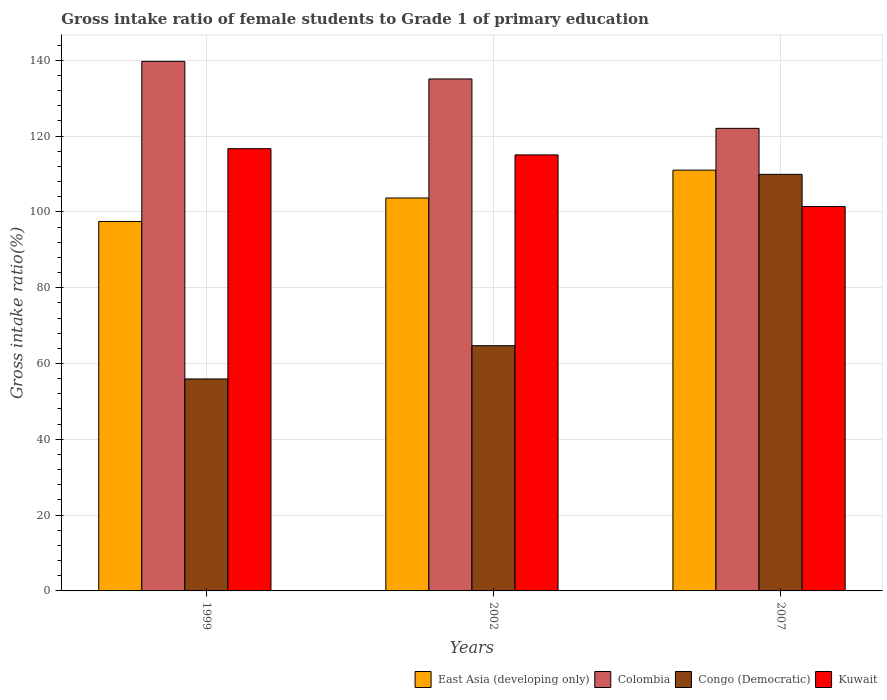How many different coloured bars are there?
Your answer should be compact. 4. Are the number of bars per tick equal to the number of legend labels?
Your answer should be very brief. Yes. Are the number of bars on each tick of the X-axis equal?
Provide a succinct answer. Yes. How many bars are there on the 2nd tick from the left?
Your response must be concise. 4. What is the gross intake ratio in Colombia in 2002?
Offer a terse response. 135.07. Across all years, what is the maximum gross intake ratio in East Asia (developing only)?
Ensure brevity in your answer.  111.01. Across all years, what is the minimum gross intake ratio in East Asia (developing only)?
Your response must be concise. 97.48. What is the total gross intake ratio in Kuwait in the graph?
Keep it short and to the point. 333.11. What is the difference between the gross intake ratio in Colombia in 1999 and that in 2002?
Provide a succinct answer. 4.64. What is the difference between the gross intake ratio in Kuwait in 2007 and the gross intake ratio in Colombia in 2002?
Your answer should be compact. -33.66. What is the average gross intake ratio in Colombia per year?
Your answer should be compact. 132.27. In the year 2002, what is the difference between the gross intake ratio in East Asia (developing only) and gross intake ratio in Colombia?
Offer a terse response. -31.41. What is the ratio of the gross intake ratio in Kuwait in 2002 to that in 2007?
Offer a terse response. 1.13. Is the gross intake ratio in Kuwait in 1999 less than that in 2007?
Offer a terse response. No. What is the difference between the highest and the second highest gross intake ratio in Congo (Democratic)?
Give a very brief answer. 45.2. What is the difference between the highest and the lowest gross intake ratio in Colombia?
Ensure brevity in your answer.  17.68. In how many years, is the gross intake ratio in Congo (Democratic) greater than the average gross intake ratio in Congo (Democratic) taken over all years?
Ensure brevity in your answer.  1. What does the 4th bar from the right in 1999 represents?
Give a very brief answer. East Asia (developing only). Is it the case that in every year, the sum of the gross intake ratio in Congo (Democratic) and gross intake ratio in East Asia (developing only) is greater than the gross intake ratio in Kuwait?
Provide a short and direct response. Yes. How many years are there in the graph?
Provide a succinct answer. 3. Are the values on the major ticks of Y-axis written in scientific E-notation?
Your response must be concise. No. Does the graph contain grids?
Keep it short and to the point. Yes. Where does the legend appear in the graph?
Your response must be concise. Bottom right. How are the legend labels stacked?
Your answer should be compact. Horizontal. What is the title of the graph?
Your answer should be compact. Gross intake ratio of female students to Grade 1 of primary education. Does "Philippines" appear as one of the legend labels in the graph?
Offer a very short reply. No. What is the label or title of the Y-axis?
Your response must be concise. Gross intake ratio(%). What is the Gross intake ratio(%) of East Asia (developing only) in 1999?
Your answer should be compact. 97.48. What is the Gross intake ratio(%) of Colombia in 1999?
Provide a short and direct response. 139.71. What is the Gross intake ratio(%) of Congo (Democratic) in 1999?
Your response must be concise. 55.92. What is the Gross intake ratio(%) of Kuwait in 1999?
Your answer should be compact. 116.68. What is the Gross intake ratio(%) in East Asia (developing only) in 2002?
Offer a terse response. 103.66. What is the Gross intake ratio(%) in Colombia in 2002?
Your answer should be compact. 135.07. What is the Gross intake ratio(%) of Congo (Democratic) in 2002?
Offer a very short reply. 64.7. What is the Gross intake ratio(%) of Kuwait in 2002?
Give a very brief answer. 115.03. What is the Gross intake ratio(%) in East Asia (developing only) in 2007?
Provide a succinct answer. 111.01. What is the Gross intake ratio(%) in Colombia in 2007?
Your response must be concise. 122.04. What is the Gross intake ratio(%) of Congo (Democratic) in 2007?
Provide a short and direct response. 109.9. What is the Gross intake ratio(%) of Kuwait in 2007?
Offer a very short reply. 101.4. Across all years, what is the maximum Gross intake ratio(%) of East Asia (developing only)?
Your answer should be compact. 111.01. Across all years, what is the maximum Gross intake ratio(%) in Colombia?
Offer a very short reply. 139.71. Across all years, what is the maximum Gross intake ratio(%) of Congo (Democratic)?
Offer a terse response. 109.9. Across all years, what is the maximum Gross intake ratio(%) in Kuwait?
Make the answer very short. 116.68. Across all years, what is the minimum Gross intake ratio(%) of East Asia (developing only)?
Your response must be concise. 97.48. Across all years, what is the minimum Gross intake ratio(%) of Colombia?
Provide a succinct answer. 122.04. Across all years, what is the minimum Gross intake ratio(%) in Congo (Democratic)?
Your answer should be compact. 55.92. Across all years, what is the minimum Gross intake ratio(%) of Kuwait?
Provide a short and direct response. 101.4. What is the total Gross intake ratio(%) of East Asia (developing only) in the graph?
Ensure brevity in your answer.  312.15. What is the total Gross intake ratio(%) in Colombia in the graph?
Provide a short and direct response. 396.82. What is the total Gross intake ratio(%) of Congo (Democratic) in the graph?
Your response must be concise. 230.52. What is the total Gross intake ratio(%) in Kuwait in the graph?
Your answer should be very brief. 333.11. What is the difference between the Gross intake ratio(%) in East Asia (developing only) in 1999 and that in 2002?
Make the answer very short. -6.19. What is the difference between the Gross intake ratio(%) of Colombia in 1999 and that in 2002?
Provide a short and direct response. 4.64. What is the difference between the Gross intake ratio(%) in Congo (Democratic) in 1999 and that in 2002?
Keep it short and to the point. -8.78. What is the difference between the Gross intake ratio(%) of Kuwait in 1999 and that in 2002?
Offer a terse response. 1.65. What is the difference between the Gross intake ratio(%) of East Asia (developing only) in 1999 and that in 2007?
Give a very brief answer. -13.53. What is the difference between the Gross intake ratio(%) of Colombia in 1999 and that in 2007?
Offer a terse response. 17.68. What is the difference between the Gross intake ratio(%) in Congo (Democratic) in 1999 and that in 2007?
Provide a short and direct response. -53.97. What is the difference between the Gross intake ratio(%) of Kuwait in 1999 and that in 2007?
Give a very brief answer. 15.27. What is the difference between the Gross intake ratio(%) of East Asia (developing only) in 2002 and that in 2007?
Make the answer very short. -7.35. What is the difference between the Gross intake ratio(%) in Colombia in 2002 and that in 2007?
Your answer should be very brief. 13.03. What is the difference between the Gross intake ratio(%) in Congo (Democratic) in 2002 and that in 2007?
Provide a short and direct response. -45.2. What is the difference between the Gross intake ratio(%) in Kuwait in 2002 and that in 2007?
Your answer should be very brief. 13.63. What is the difference between the Gross intake ratio(%) in East Asia (developing only) in 1999 and the Gross intake ratio(%) in Colombia in 2002?
Ensure brevity in your answer.  -37.59. What is the difference between the Gross intake ratio(%) of East Asia (developing only) in 1999 and the Gross intake ratio(%) of Congo (Democratic) in 2002?
Your response must be concise. 32.77. What is the difference between the Gross intake ratio(%) of East Asia (developing only) in 1999 and the Gross intake ratio(%) of Kuwait in 2002?
Offer a terse response. -17.56. What is the difference between the Gross intake ratio(%) of Colombia in 1999 and the Gross intake ratio(%) of Congo (Democratic) in 2002?
Provide a short and direct response. 75.01. What is the difference between the Gross intake ratio(%) in Colombia in 1999 and the Gross intake ratio(%) in Kuwait in 2002?
Give a very brief answer. 24.68. What is the difference between the Gross intake ratio(%) in Congo (Democratic) in 1999 and the Gross intake ratio(%) in Kuwait in 2002?
Offer a very short reply. -59.11. What is the difference between the Gross intake ratio(%) of East Asia (developing only) in 1999 and the Gross intake ratio(%) of Colombia in 2007?
Offer a very short reply. -24.56. What is the difference between the Gross intake ratio(%) of East Asia (developing only) in 1999 and the Gross intake ratio(%) of Congo (Democratic) in 2007?
Your response must be concise. -12.42. What is the difference between the Gross intake ratio(%) of East Asia (developing only) in 1999 and the Gross intake ratio(%) of Kuwait in 2007?
Give a very brief answer. -3.93. What is the difference between the Gross intake ratio(%) in Colombia in 1999 and the Gross intake ratio(%) in Congo (Democratic) in 2007?
Offer a very short reply. 29.82. What is the difference between the Gross intake ratio(%) in Colombia in 1999 and the Gross intake ratio(%) in Kuwait in 2007?
Make the answer very short. 38.31. What is the difference between the Gross intake ratio(%) of Congo (Democratic) in 1999 and the Gross intake ratio(%) of Kuwait in 2007?
Give a very brief answer. -45.48. What is the difference between the Gross intake ratio(%) of East Asia (developing only) in 2002 and the Gross intake ratio(%) of Colombia in 2007?
Provide a short and direct response. -18.37. What is the difference between the Gross intake ratio(%) of East Asia (developing only) in 2002 and the Gross intake ratio(%) of Congo (Democratic) in 2007?
Ensure brevity in your answer.  -6.23. What is the difference between the Gross intake ratio(%) in East Asia (developing only) in 2002 and the Gross intake ratio(%) in Kuwait in 2007?
Keep it short and to the point. 2.26. What is the difference between the Gross intake ratio(%) in Colombia in 2002 and the Gross intake ratio(%) in Congo (Democratic) in 2007?
Provide a succinct answer. 25.17. What is the difference between the Gross intake ratio(%) of Colombia in 2002 and the Gross intake ratio(%) of Kuwait in 2007?
Provide a short and direct response. 33.66. What is the difference between the Gross intake ratio(%) of Congo (Democratic) in 2002 and the Gross intake ratio(%) of Kuwait in 2007?
Offer a very short reply. -36.7. What is the average Gross intake ratio(%) in East Asia (developing only) per year?
Keep it short and to the point. 104.05. What is the average Gross intake ratio(%) in Colombia per year?
Your answer should be very brief. 132.27. What is the average Gross intake ratio(%) in Congo (Democratic) per year?
Offer a very short reply. 76.84. What is the average Gross intake ratio(%) in Kuwait per year?
Give a very brief answer. 111.04. In the year 1999, what is the difference between the Gross intake ratio(%) of East Asia (developing only) and Gross intake ratio(%) of Colombia?
Ensure brevity in your answer.  -42.24. In the year 1999, what is the difference between the Gross intake ratio(%) of East Asia (developing only) and Gross intake ratio(%) of Congo (Democratic)?
Provide a short and direct response. 41.55. In the year 1999, what is the difference between the Gross intake ratio(%) in East Asia (developing only) and Gross intake ratio(%) in Kuwait?
Give a very brief answer. -19.2. In the year 1999, what is the difference between the Gross intake ratio(%) in Colombia and Gross intake ratio(%) in Congo (Democratic)?
Provide a succinct answer. 83.79. In the year 1999, what is the difference between the Gross intake ratio(%) of Colombia and Gross intake ratio(%) of Kuwait?
Offer a terse response. 23.04. In the year 1999, what is the difference between the Gross intake ratio(%) of Congo (Democratic) and Gross intake ratio(%) of Kuwait?
Your answer should be very brief. -60.75. In the year 2002, what is the difference between the Gross intake ratio(%) of East Asia (developing only) and Gross intake ratio(%) of Colombia?
Your response must be concise. -31.41. In the year 2002, what is the difference between the Gross intake ratio(%) in East Asia (developing only) and Gross intake ratio(%) in Congo (Democratic)?
Give a very brief answer. 38.96. In the year 2002, what is the difference between the Gross intake ratio(%) of East Asia (developing only) and Gross intake ratio(%) of Kuwait?
Give a very brief answer. -11.37. In the year 2002, what is the difference between the Gross intake ratio(%) in Colombia and Gross intake ratio(%) in Congo (Democratic)?
Ensure brevity in your answer.  70.37. In the year 2002, what is the difference between the Gross intake ratio(%) of Colombia and Gross intake ratio(%) of Kuwait?
Your answer should be compact. 20.04. In the year 2002, what is the difference between the Gross intake ratio(%) in Congo (Democratic) and Gross intake ratio(%) in Kuwait?
Make the answer very short. -50.33. In the year 2007, what is the difference between the Gross intake ratio(%) in East Asia (developing only) and Gross intake ratio(%) in Colombia?
Provide a succinct answer. -11.03. In the year 2007, what is the difference between the Gross intake ratio(%) in East Asia (developing only) and Gross intake ratio(%) in Congo (Democratic)?
Ensure brevity in your answer.  1.11. In the year 2007, what is the difference between the Gross intake ratio(%) in East Asia (developing only) and Gross intake ratio(%) in Kuwait?
Offer a terse response. 9.6. In the year 2007, what is the difference between the Gross intake ratio(%) in Colombia and Gross intake ratio(%) in Congo (Democratic)?
Offer a very short reply. 12.14. In the year 2007, what is the difference between the Gross intake ratio(%) in Colombia and Gross intake ratio(%) in Kuwait?
Ensure brevity in your answer.  20.63. In the year 2007, what is the difference between the Gross intake ratio(%) of Congo (Democratic) and Gross intake ratio(%) of Kuwait?
Make the answer very short. 8.49. What is the ratio of the Gross intake ratio(%) of East Asia (developing only) in 1999 to that in 2002?
Your response must be concise. 0.94. What is the ratio of the Gross intake ratio(%) of Colombia in 1999 to that in 2002?
Provide a succinct answer. 1.03. What is the ratio of the Gross intake ratio(%) of Congo (Democratic) in 1999 to that in 2002?
Provide a short and direct response. 0.86. What is the ratio of the Gross intake ratio(%) of Kuwait in 1999 to that in 2002?
Offer a very short reply. 1.01. What is the ratio of the Gross intake ratio(%) in East Asia (developing only) in 1999 to that in 2007?
Ensure brevity in your answer.  0.88. What is the ratio of the Gross intake ratio(%) of Colombia in 1999 to that in 2007?
Provide a succinct answer. 1.14. What is the ratio of the Gross intake ratio(%) in Congo (Democratic) in 1999 to that in 2007?
Provide a succinct answer. 0.51. What is the ratio of the Gross intake ratio(%) in Kuwait in 1999 to that in 2007?
Your answer should be compact. 1.15. What is the ratio of the Gross intake ratio(%) of East Asia (developing only) in 2002 to that in 2007?
Offer a terse response. 0.93. What is the ratio of the Gross intake ratio(%) in Colombia in 2002 to that in 2007?
Offer a terse response. 1.11. What is the ratio of the Gross intake ratio(%) of Congo (Democratic) in 2002 to that in 2007?
Ensure brevity in your answer.  0.59. What is the ratio of the Gross intake ratio(%) of Kuwait in 2002 to that in 2007?
Make the answer very short. 1.13. What is the difference between the highest and the second highest Gross intake ratio(%) in East Asia (developing only)?
Make the answer very short. 7.35. What is the difference between the highest and the second highest Gross intake ratio(%) of Colombia?
Your response must be concise. 4.64. What is the difference between the highest and the second highest Gross intake ratio(%) of Congo (Democratic)?
Give a very brief answer. 45.2. What is the difference between the highest and the second highest Gross intake ratio(%) of Kuwait?
Ensure brevity in your answer.  1.65. What is the difference between the highest and the lowest Gross intake ratio(%) of East Asia (developing only)?
Provide a succinct answer. 13.53. What is the difference between the highest and the lowest Gross intake ratio(%) of Colombia?
Keep it short and to the point. 17.68. What is the difference between the highest and the lowest Gross intake ratio(%) in Congo (Democratic)?
Your answer should be very brief. 53.97. What is the difference between the highest and the lowest Gross intake ratio(%) of Kuwait?
Ensure brevity in your answer.  15.27. 